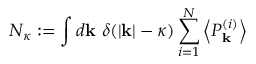<formula> <loc_0><loc_0><loc_500><loc_500>N _ { \kappa } \colon = \int d \mathbf k \ \delta ( | \mathbf k | - \kappa ) \sum _ { i = 1 } ^ { N } \left < P _ { \mathbf k } ^ { ( i ) } \right ></formula> 